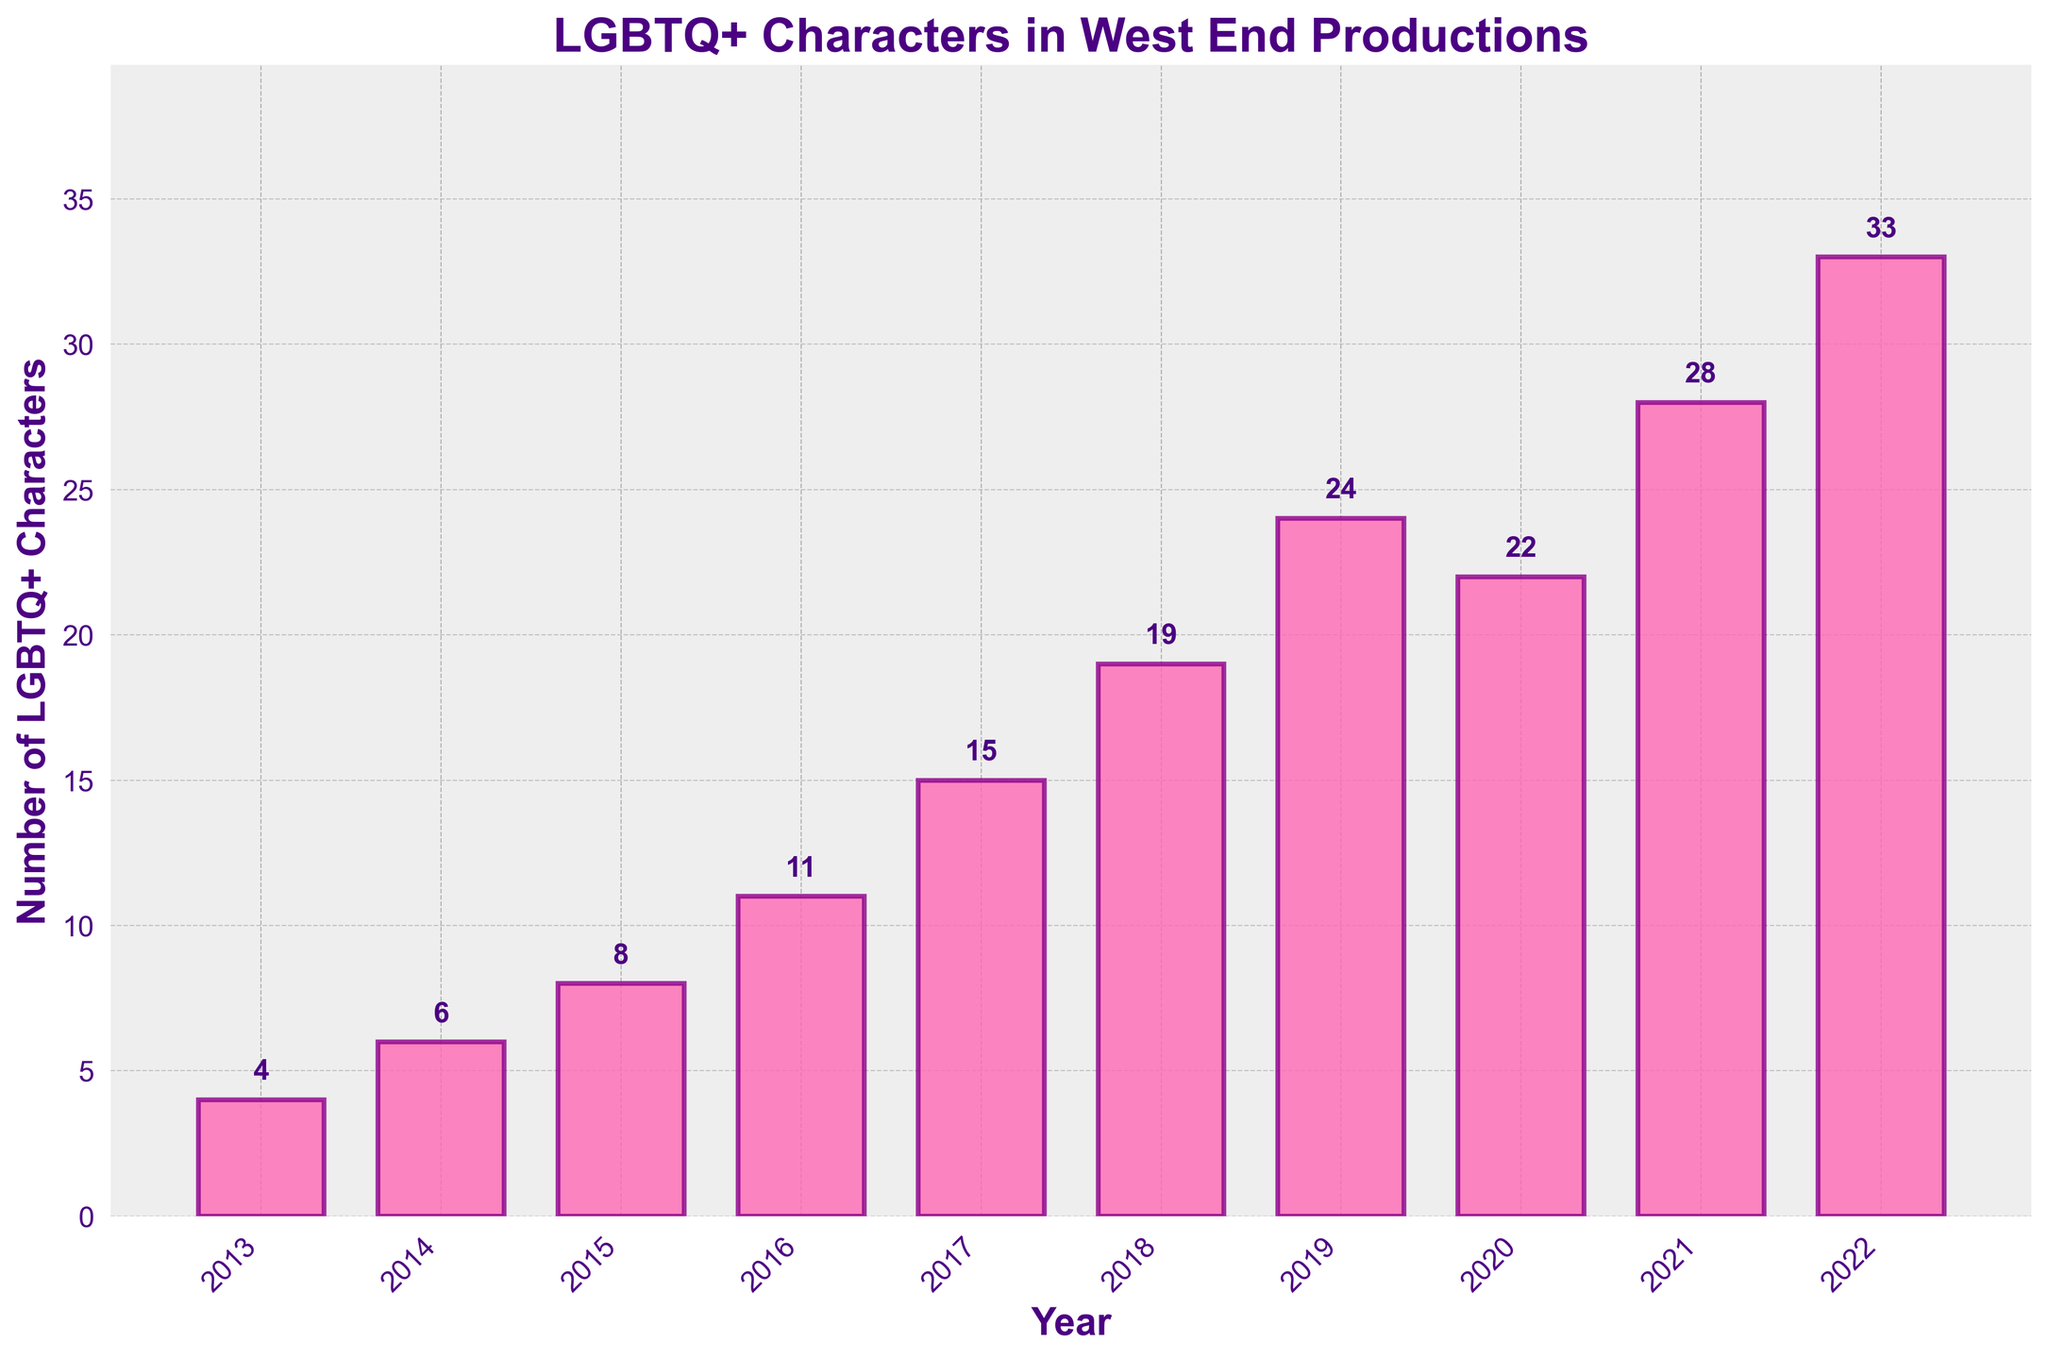What is the overall trend in the number of LGBTQ+ characters in West End productions from 2013 to 2022? The number of LGBTQ+ characters consistently increases each year from 2013 to 2022.
Answer: Increasing trend Which year saw the highest number of LGBTQ+ characters in West End productions? In 2022, the number of LGBTQ+ characters peaked at 33, the highest in the decade.
Answer: 2022 How many more LGBTQ+ characters were there in 2022 compared to 2013? Subtract the number of characters in 2013 from the number in 2022: 33 - 4 = 29.
Answer: 29 How does the number of LGBTQ+ characters in 2020 compare to 2019? In 2020, there were 22 LGBTQ+ characters, while in 2019, there were 24. So, 2020 had 2 fewer characters compared to 2019.
Answer: 2 fewer Which year saw the most significant increase in the number of LGBTQ+ characters compared to the previous year? Calculating the year-over-year differences: 
2014 (6-4) = 2, 
2015 (8-6) = 2, 
2016 (11-8) = 3, 
2017 (15-11) = 4, 
2018 (19-15) = 4, 
2019 (24-19) = 5, 
2020 (22-24) = -2, 
2021 (28-22) = 6, 
2022 (33-28) = 5.
The most significant increase occurred from 2020 to 2021 with an increase of 6 characters.
Answer: 2021 On average, how many LGBTQ+ characters were represented per year over this decade? Sum the total number of characters and divide by the number of years: (4+6+8+11+15+19+24+22+28+33) / 10 = 170 / 10 = 17.
Answer: 17 Which two consecutive years had the smallest change in the number of LGBTQ+ characters? By comparing the differences between consecutive years:
2014-2013: 2, 
2015-2014: 2, 
2016-2015: 3, 
2017-2016: 4, 
2018-2017: 4, 
2019-2018: 5, 
2020-2019: -2, 
2021-2020: 6, 
2022-2021: 5.
The smallest change of 2 characters occurred between both 2013-2014 and 2014-2015.
Answer: 2013-2014 and 2014-2015 What is the average number of LGBTQ+ characters from 2018 to 2022? Sum the number of characters from 2018 to 2022 and divide by the number of years: (19+24+22+28+33) / 5 = 126 / 5 = 25.2
Answer: 25.2 What is the difference between the maximum and minimum numbers of LGBTQ+ characters over the past decade? Subtract the minimum value (2013: 4) from the maximum value (2022: 33): 33 - 4 = 29.
Answer: 29 How many LGBTQ+ characters were added in total from 2013 to 2017? Sum the characters from 2013 to 2017: 4 + 6 + 8 + 11 + 15 = 44.
Answer: 44 